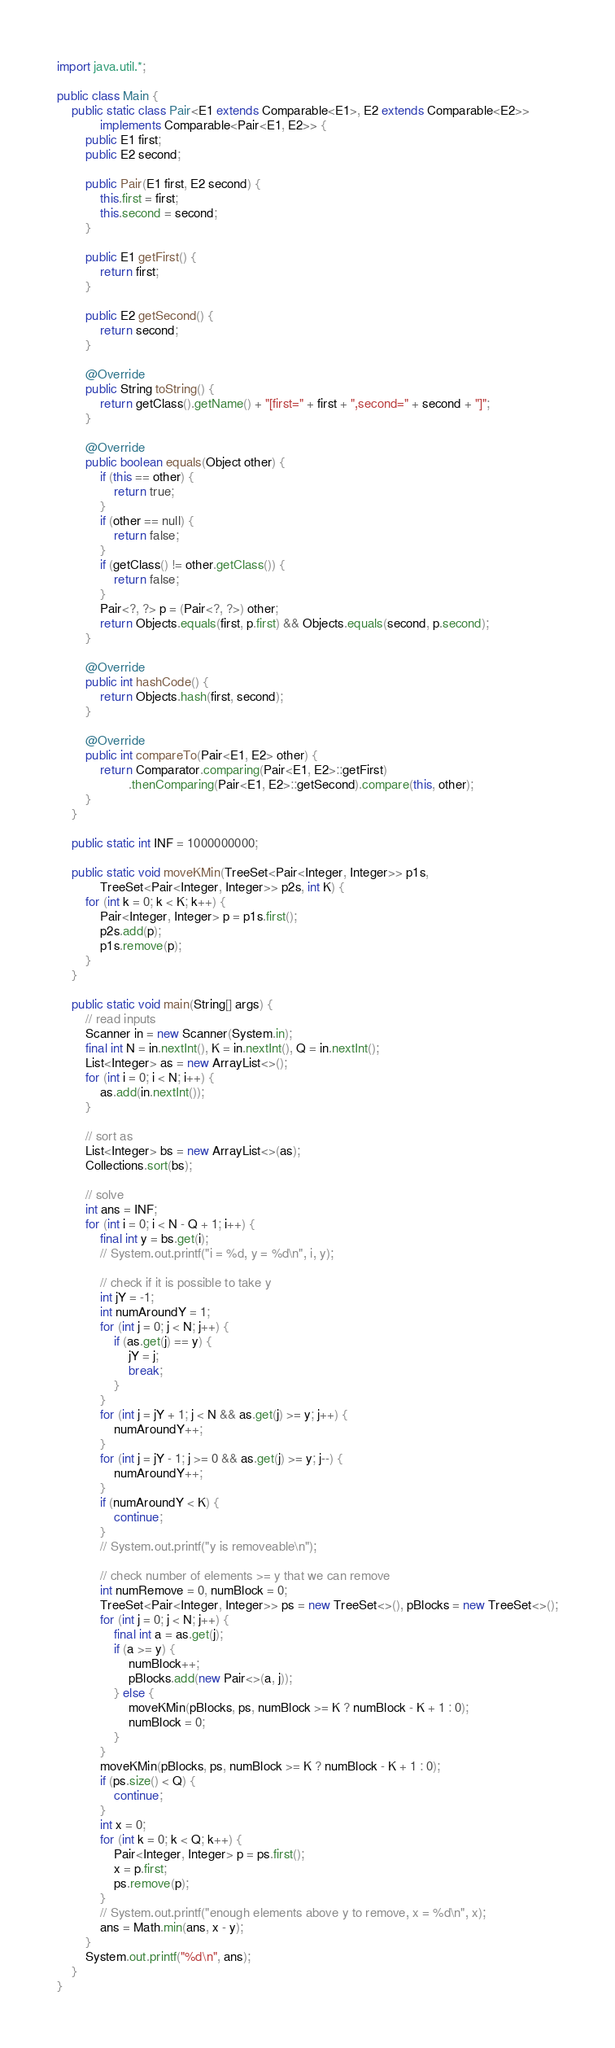<code> <loc_0><loc_0><loc_500><loc_500><_Java_>import java.util.*;

public class Main {
    public static class Pair<E1 extends Comparable<E1>, E2 extends Comparable<E2>>
            implements Comparable<Pair<E1, E2>> {
        public E1 first;
        public E2 second;

        public Pair(E1 first, E2 second) {
            this.first = first;
            this.second = second;
        }

        public E1 getFirst() {
            return first;
        }

        public E2 getSecond() {
            return second;
        }

        @Override
        public String toString() {
            return getClass().getName() + "[first=" + first + ",second=" + second + "]";
        }

        @Override
        public boolean equals(Object other) {
            if (this == other) {
                return true;
            }
            if (other == null) {
                return false;
            }
            if (getClass() != other.getClass()) {
                return false;
            }
            Pair<?, ?> p = (Pair<?, ?>) other;
            return Objects.equals(first, p.first) && Objects.equals(second, p.second);
        }

        @Override
        public int hashCode() {
            return Objects.hash(first, second);
        }

        @Override
        public int compareTo(Pair<E1, E2> other) {
            return Comparator.comparing(Pair<E1, E2>::getFirst)
                    .thenComparing(Pair<E1, E2>::getSecond).compare(this, other);
        }
    }

    public static int INF = 1000000000;

    public static void moveKMin(TreeSet<Pair<Integer, Integer>> p1s,
            TreeSet<Pair<Integer, Integer>> p2s, int K) {
        for (int k = 0; k < K; k++) {
            Pair<Integer, Integer> p = p1s.first();
            p2s.add(p);
            p1s.remove(p);
        }
    }

    public static void main(String[] args) {
        // read inputs
        Scanner in = new Scanner(System.in);
        final int N = in.nextInt(), K = in.nextInt(), Q = in.nextInt();
        List<Integer> as = new ArrayList<>();
        for (int i = 0; i < N; i++) {
            as.add(in.nextInt());
        }

        // sort as
        List<Integer> bs = new ArrayList<>(as);
        Collections.sort(bs);

        // solve
        int ans = INF;
        for (int i = 0; i < N - Q + 1; i++) {
            final int y = bs.get(i);
            // System.out.printf("i = %d, y = %d\n", i, y);

            // check if it is possible to take y
            int jY = -1;
            int numAroundY = 1;
            for (int j = 0; j < N; j++) {
                if (as.get(j) == y) {
                    jY = j;
                    break;
                }
            }
            for (int j = jY + 1; j < N && as.get(j) >= y; j++) {
                numAroundY++;
            }
            for (int j = jY - 1; j >= 0 && as.get(j) >= y; j--) {
                numAroundY++;
            }
            if (numAroundY < K) {
                continue;
            }
            // System.out.printf("y is removeable\n");

            // check number of elements >= y that we can remove
            int numRemove = 0, numBlock = 0;
            TreeSet<Pair<Integer, Integer>> ps = new TreeSet<>(), pBlocks = new TreeSet<>();
            for (int j = 0; j < N; j++) {
                final int a = as.get(j);
                if (a >= y) {
                    numBlock++;
                    pBlocks.add(new Pair<>(a, j));
                } else {
                    moveKMin(pBlocks, ps, numBlock >= K ? numBlock - K + 1 : 0);
                    numBlock = 0;
                }
            }
            moveKMin(pBlocks, ps, numBlock >= K ? numBlock - K + 1 : 0);
            if (ps.size() < Q) {
                continue;
            }
            int x = 0;
            for (int k = 0; k < Q; k++) {
                Pair<Integer, Integer> p = ps.first();
                x = p.first;
                ps.remove(p);
            }
            // System.out.printf("enough elements above y to remove, x = %d\n", x);
            ans = Math.min(ans, x - y);
        }
        System.out.printf("%d\n", ans);
    }
}
</code> 